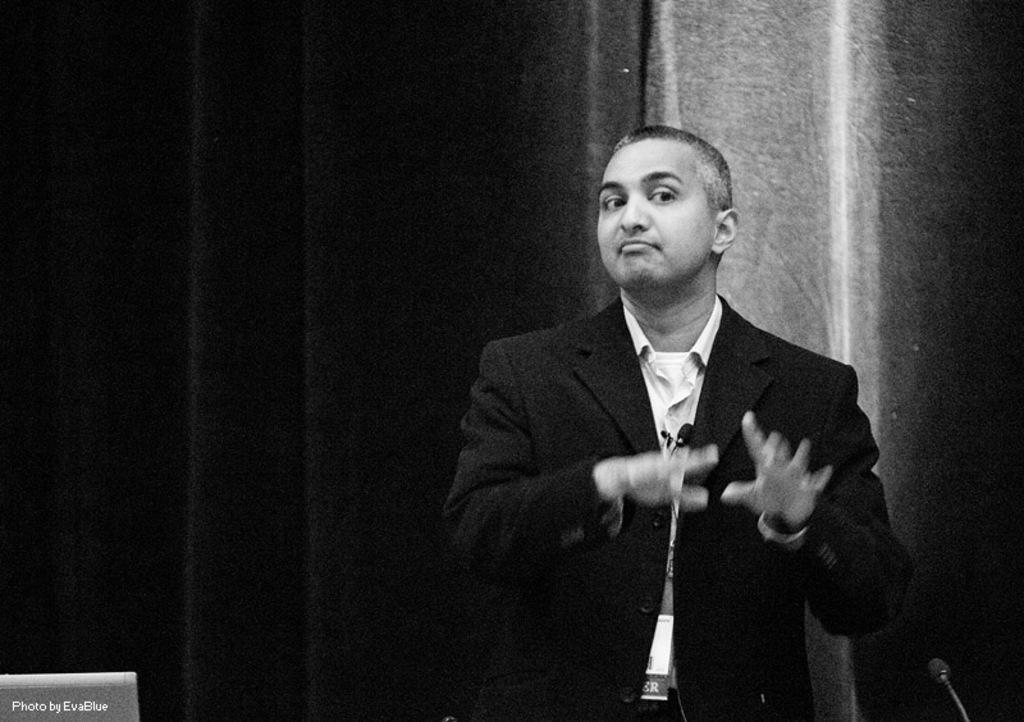Can you describe this image briefly? In the picture I can see a man on the right side and he is indicating something with his hands. He is wearing a shirt and suit. I can see the microphone on the bottom right side of the picture. In the background, I can see the curtain. 